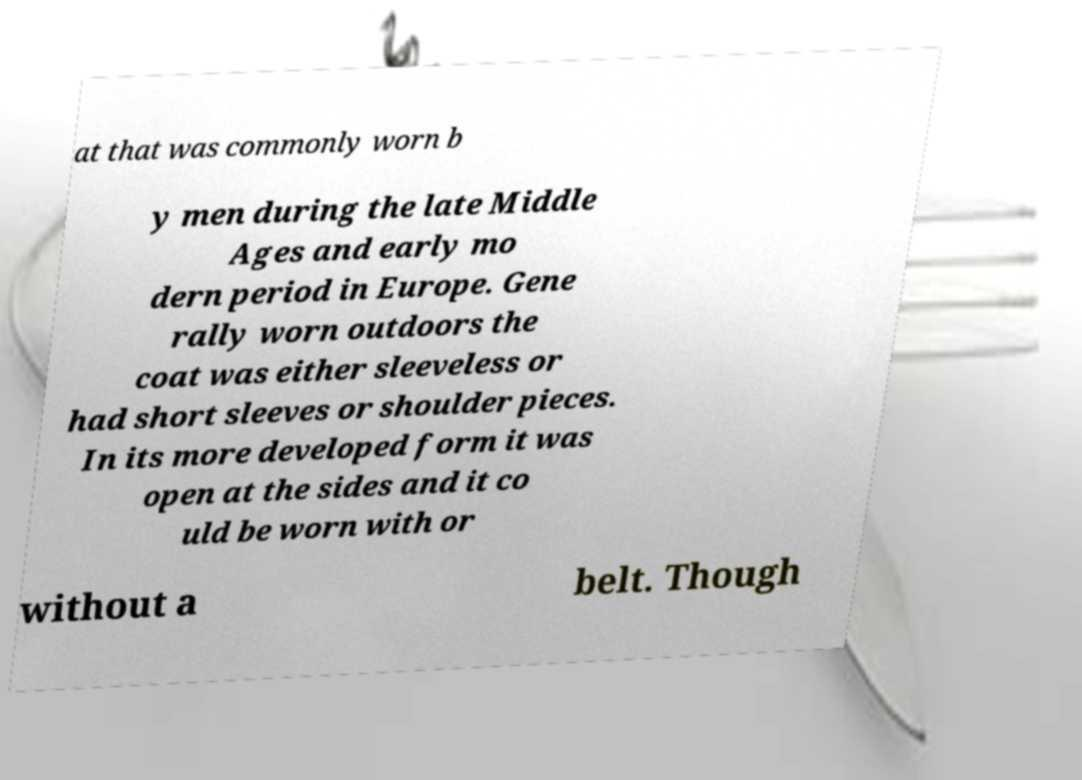Can you accurately transcribe the text from the provided image for me? at that was commonly worn b y men during the late Middle Ages and early mo dern period in Europe. Gene rally worn outdoors the coat was either sleeveless or had short sleeves or shoulder pieces. In its more developed form it was open at the sides and it co uld be worn with or without a belt. Though 